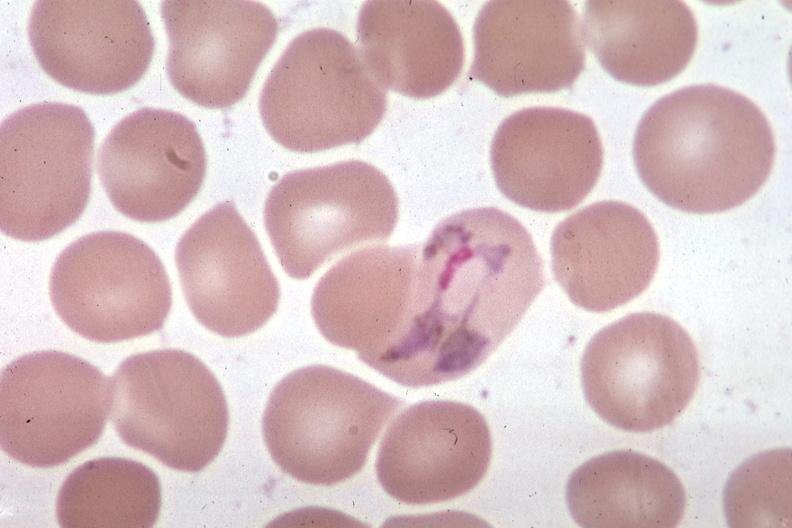s hemangioma present?
Answer the question using a single word or phrase. No 